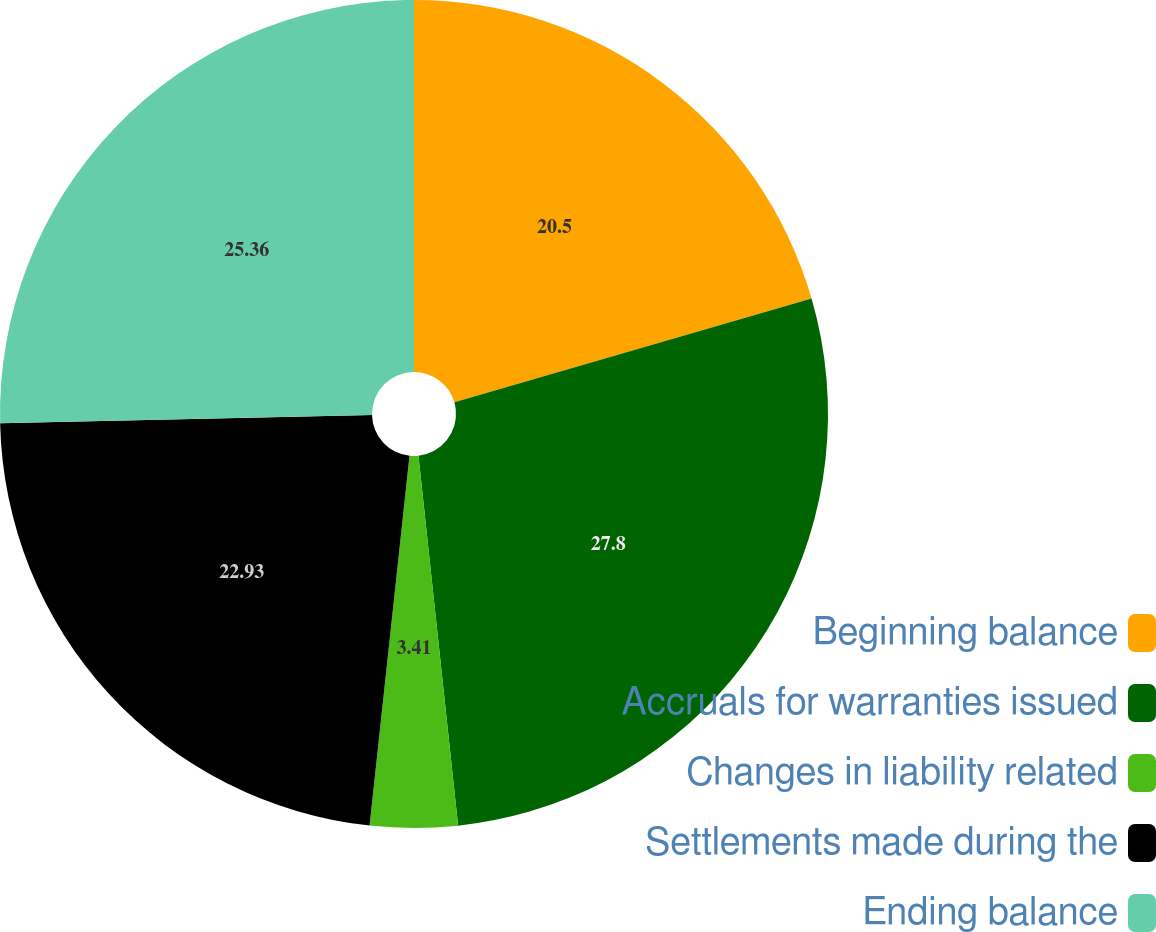Convert chart to OTSL. <chart><loc_0><loc_0><loc_500><loc_500><pie_chart><fcel>Beginning balance<fcel>Accruals for warranties issued<fcel>Changes in liability related<fcel>Settlements made during the<fcel>Ending balance<nl><fcel>20.5%<fcel>27.8%<fcel>3.41%<fcel>22.93%<fcel>25.36%<nl></chart> 